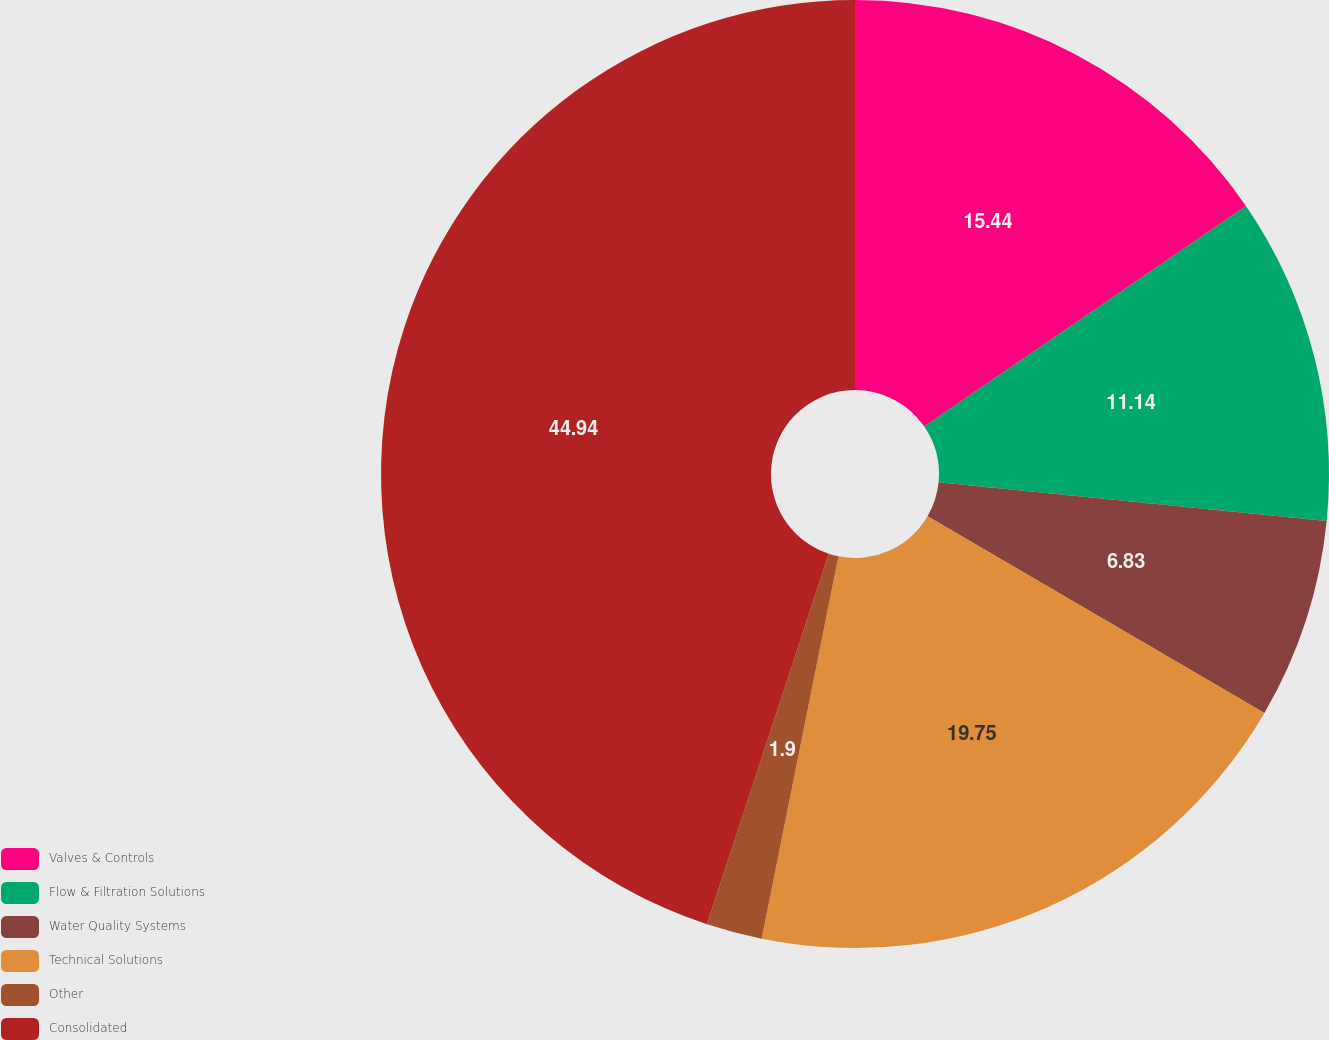Convert chart to OTSL. <chart><loc_0><loc_0><loc_500><loc_500><pie_chart><fcel>Valves & Controls<fcel>Flow & Filtration Solutions<fcel>Water Quality Systems<fcel>Technical Solutions<fcel>Other<fcel>Consolidated<nl><fcel>15.44%<fcel>11.14%<fcel>6.83%<fcel>19.75%<fcel>1.9%<fcel>44.95%<nl></chart> 